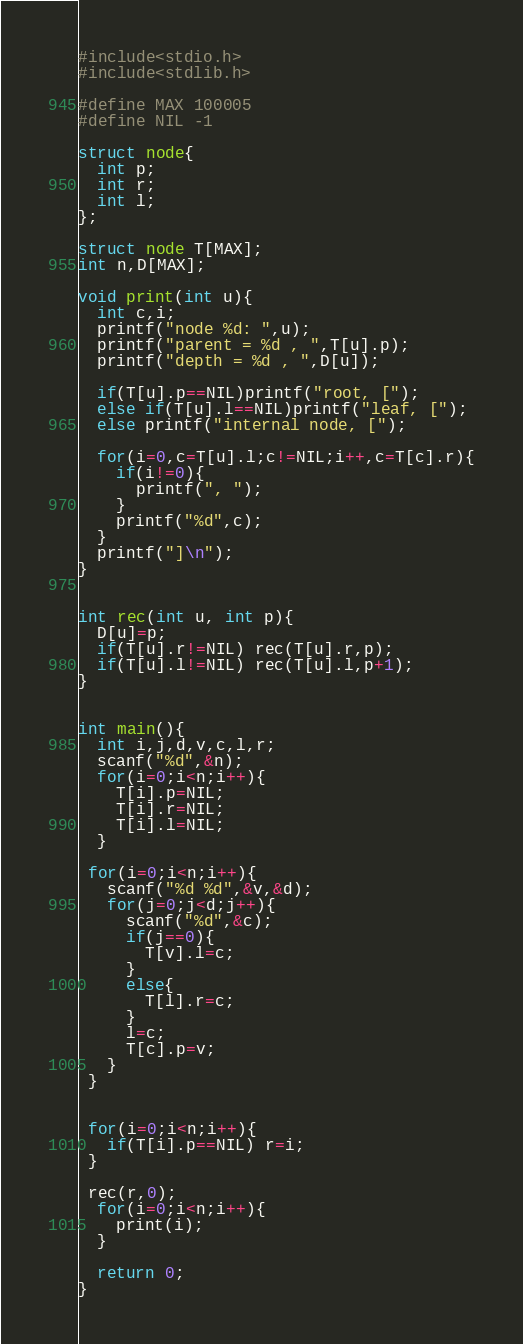Convert code to text. <code><loc_0><loc_0><loc_500><loc_500><_C_>#include<stdio.h>
#include<stdlib.h>

#define MAX 100005
#define NIL -1

struct node{
  int p;
  int r;
  int l;
};

struct node T[MAX];
int n,D[MAX];

void print(int u){
  int c,i;
  printf("node %d: ",u);
  printf("parent = %d , ",T[u].p);
  printf("depth = %d , ",D[u]);
  
  if(T[u].p==NIL)printf("root, [");
  else if(T[u].l==NIL)printf("leaf, [");
  else printf("internal node, [");

  for(i=0,c=T[u].l;c!=NIL;i++,c=T[c].r){
    if(i!=0){
      printf(", ");
    }
    printf("%d",c);
  }
  printf("]\n");
}


int rec(int u, int p){
  D[u]=p;
  if(T[u].r!=NIL) rec(T[u].r,p);
  if(T[u].l!=NIL) rec(T[u].l,p+1);
}


int main(){
  int i,j,d,v,c,l,r;
  scanf("%d",&n);
  for(i=0;i<n;i++){
    T[i].p=NIL;
    T[i].r=NIL;
    T[i].l=NIL;
  }
  
 for(i=0;i<n;i++){
   scanf("%d %d",&v,&d);
   for(j=0;j<d;j++){
     scanf("%d",&c);
     if(j==0){
       T[v].l=c;
     }
     else{
       T[l].r=c;
     }
     l=c;
     T[c].p=v;
   }
 }

 
 for(i=0;i<n;i++){
   if(T[i].p==NIL) r=i;
 }

 rec(r,0);
  for(i=0;i<n;i++){
    print(i);
  }

  return 0;
}

</code> 